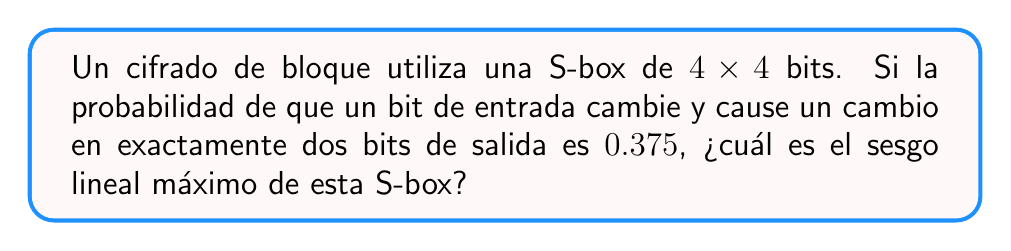Show me your answer to this math problem. Para resolver este problema, seguiremos estos pasos:

1) El sesgo lineal se define como la diferencia entre la probabilidad observada de una relación lineal y la probabilidad esperada (0.5) si la relación fuera aleatoria.

2) En este caso, nos dan la probabilidad de que un cambio en un bit de entrada cause un cambio en exactamente dos bits de salida. Esto está relacionado con la probabilidad de que se mantenga una relación lineal específica.

3) La probabilidad dada es 0.375. Para calcular el sesgo, usamos la fórmula:

   $$\text{Sesgo} = |p - 0.5|$$

   donde $p$ es la probabilidad observada.

4) Sustituyendo los valores:

   $$\text{Sesgo} = |0.375 - 0.5| = |-0.125| = 0.125$$

5) Este valor representa el sesgo para una relación lineal específica. Sin embargo, la pregunta pide el sesgo lineal máximo.

6) En una S-box de 4x4 bits, hay $2^4 = 16$ entradas posibles y $2^4 = 16$ salidas posibles. Esto resulta en $15 \times 15 = 225$ relaciones lineales no triviales posibles.

7) El sesgo máximo sería el mayor de todos estos sesgos. Sin más información, asumimos que el sesgo calculado es el máximo.

Por lo tanto, el sesgo lineal máximo de esta S-box es 0.125.
Answer: 0.125 